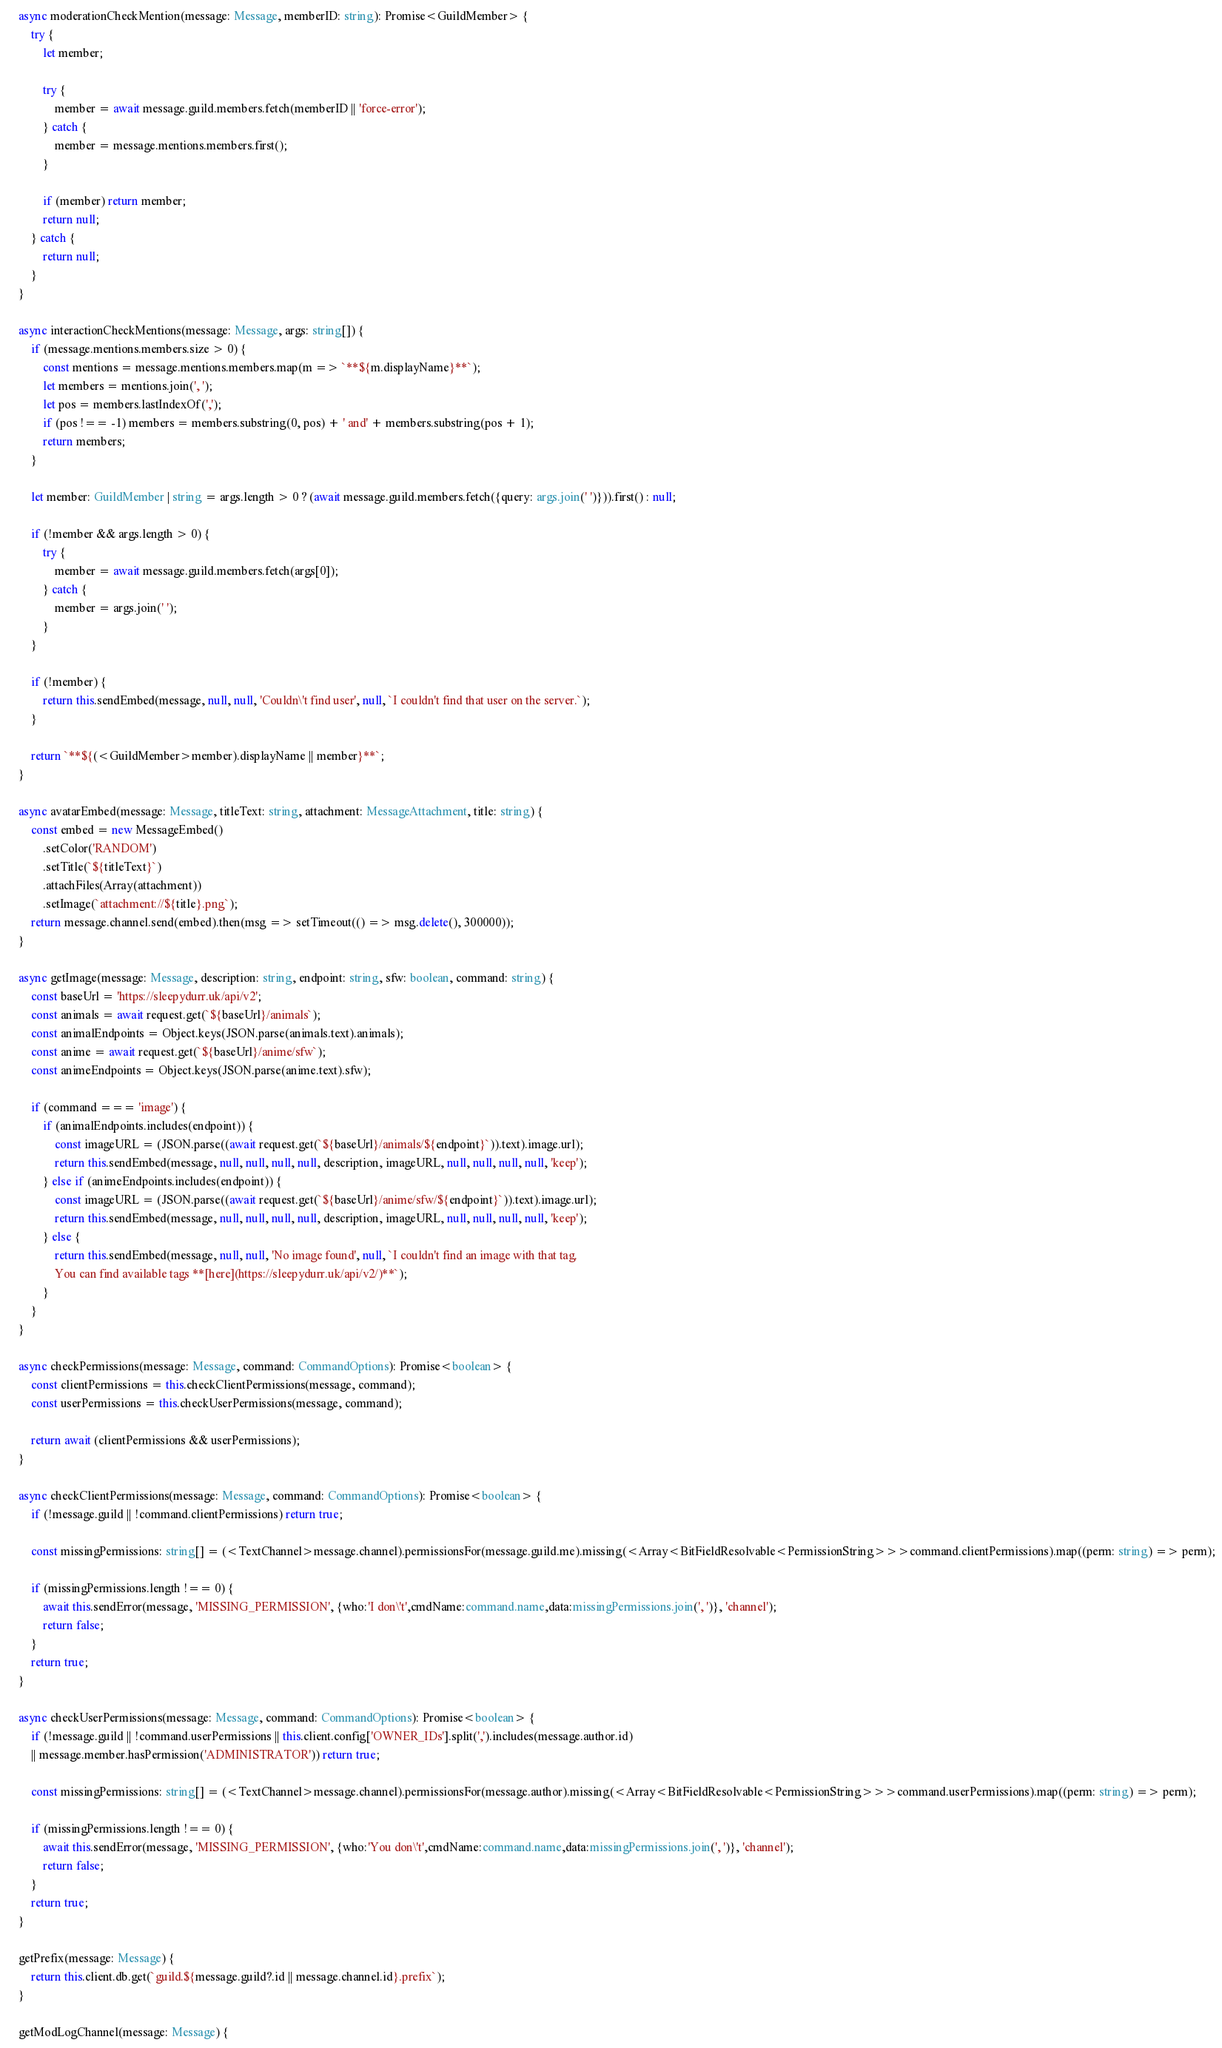<code> <loc_0><loc_0><loc_500><loc_500><_TypeScript_>
    async moderationCheckMention(message: Message, memberID: string): Promise<GuildMember> {
        try {
            let member;

            try {
                member = await message.guild.members.fetch(memberID || 'force-error');
            } catch {
                member = message.mentions.members.first();
            }

            if (member) return member;
            return null;
        } catch {
            return null;
        }
    }

    async interactionCheckMentions(message: Message, args: string[]) {
        if (message.mentions.members.size > 0) {
            const mentions = message.mentions.members.map(m => `**${m.displayName}**`);
            let members = mentions.join(', ');
            let pos = members.lastIndexOf(',');
            if (pos !== -1) members = members.substring(0, pos) + ' and' + members.substring(pos + 1);
            return members;
        }

        let member: GuildMember | string = args.length > 0 ? (await message.guild.members.fetch({query: args.join(' ')})).first() : null;

        if (!member && args.length > 0) {
            try {
                member = await message.guild.members.fetch(args[0]);
            } catch {
                member = args.join(' ');
            }
        }

        if (!member) {
            return this.sendEmbed(message, null, null, 'Couldn\'t find user', null, `I couldn't find that user on the server.`);
        }

        return `**${(<GuildMember>member).displayName || member}**`;
    }

    async avatarEmbed(message: Message, titleText: string, attachment: MessageAttachment, title: string) {
        const embed = new MessageEmbed()
            .setColor('RANDOM')
            .setTitle(`${titleText}`)
            .attachFiles(Array(attachment))
            .setImage(`attachment://${title}.png`);
        return message.channel.send(embed).then(msg => setTimeout(() => msg.delete(), 300000));
    }

    async getImage(message: Message, description: string, endpoint: string, sfw: boolean, command: string) {
        const baseUrl = 'https://sleepydurr.uk/api/v2';
        const animals = await request.get(`${baseUrl}/animals`);
        const animalEndpoints = Object.keys(JSON.parse(animals.text).animals);
        const anime = await request.get(`${baseUrl}/anime/sfw`);
        const animeEndpoints = Object.keys(JSON.parse(anime.text).sfw);

        if (command === 'image') {
            if (animalEndpoints.includes(endpoint)) {
                const imageURL = (JSON.parse((await request.get(`${baseUrl}/animals/${endpoint}`)).text).image.url);
                return this.sendEmbed(message, null, null, null, null, description, imageURL, null, null, null, null, 'keep');
            } else if (animeEndpoints.includes(endpoint)) {
                const imageURL = (JSON.parse((await request.get(`${baseUrl}/anime/sfw/${endpoint}`)).text).image.url);
                return this.sendEmbed(message, null, null, null, null, description, imageURL, null, null, null, null, 'keep');
            } else {
                return this.sendEmbed(message, null, null, 'No image found', null, `I couldn't find an image with that tag.
                You can find available tags **[here](https://sleepydurr.uk/api/v2/)**`);
            }
        }
    }

    async checkPermissions(message: Message, command: CommandOptions): Promise<boolean> {
        const clientPermissions = this.checkClientPermissions(message, command);
        const userPermissions = this.checkUserPermissions(message, command);

        return await (clientPermissions && userPermissions);
    }

    async checkClientPermissions(message: Message, command: CommandOptions): Promise<boolean> {
        if (!message.guild || !command.clientPermissions) return true;

        const missingPermissions: string[] = (<TextChannel>message.channel).permissionsFor(message.guild.me).missing(<Array<BitFieldResolvable<PermissionString>>>command.clientPermissions).map((perm: string) => perm);

        if (missingPermissions.length !== 0) {
            await this.sendError(message, 'MISSING_PERMISSION', {who:'I don\'t',cmdName:command.name,data:missingPermissions.join(', ')}, 'channel');
            return false;
        }
        return true;
    }

    async checkUserPermissions(message: Message, command: CommandOptions): Promise<boolean> {
        if (!message.guild || !command.userPermissions || this.client.config['OWNER_IDs'].split(',').includes(message.author.id)
        || message.member.hasPermission('ADMINISTRATOR')) return true;

        const missingPermissions: string[] = (<TextChannel>message.channel).permissionsFor(message.author).missing(<Array<BitFieldResolvable<PermissionString>>>command.userPermissions).map((perm: string) => perm);

        if (missingPermissions.length !== 0) {
            await this.sendError(message, 'MISSING_PERMISSION', {who:'You don\'t',cmdName:command.name,data:missingPermissions.join(', ')}, 'channel');
            return false;
        }
        return true;
    }

    getPrefix(message: Message) {
        return this.client.db.get(`guild.${message.guild?.id || message.channel.id}.prefix`);
    }

    getModLogChannel(message: Message) {</code> 